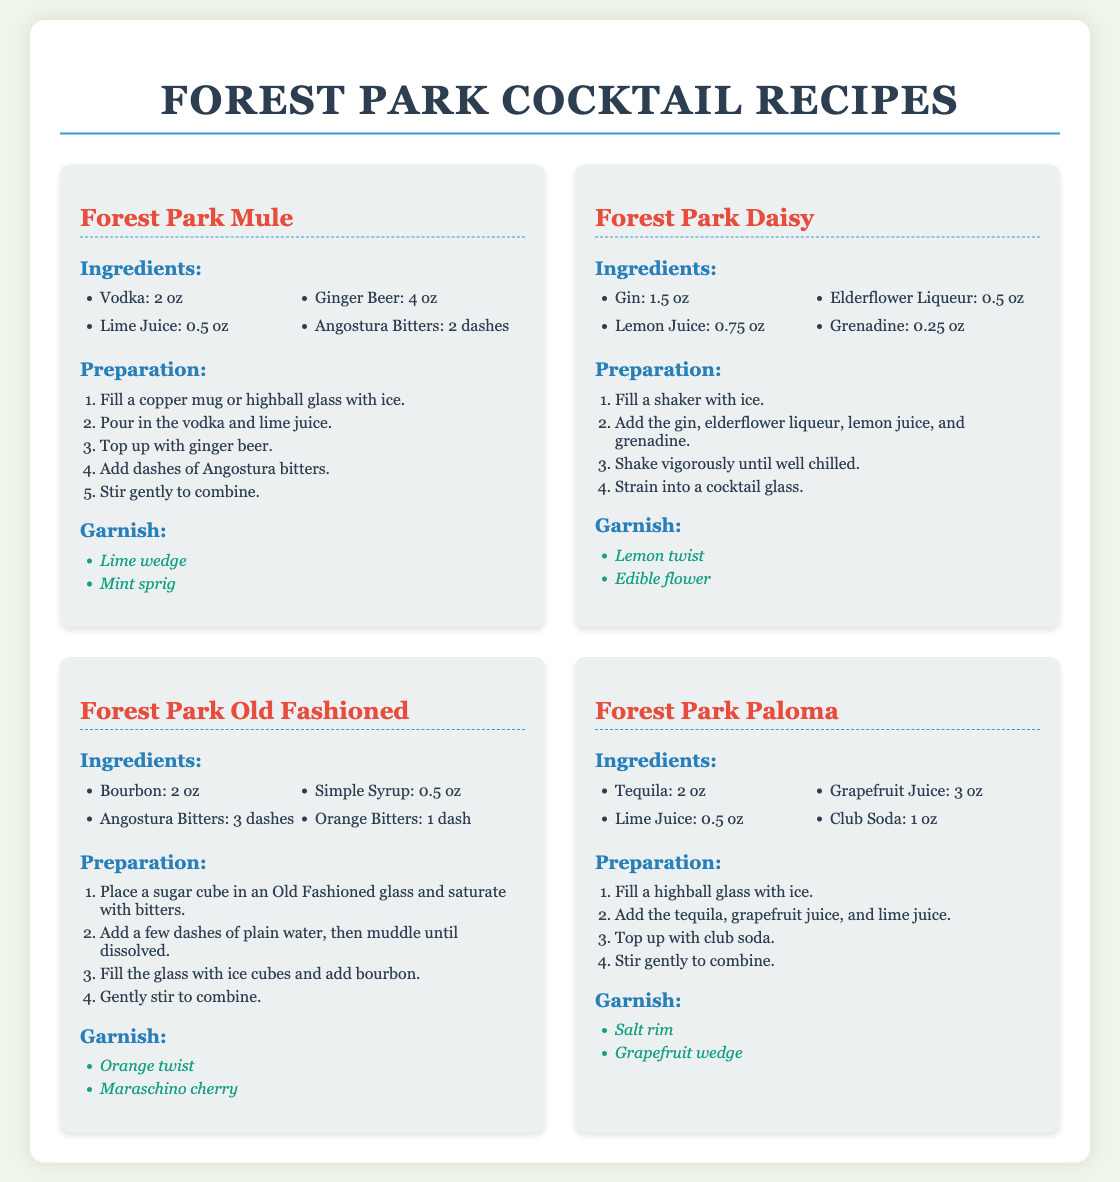What is the first cocktail listed? The first cocktail shown in the recipe card is "Forest Park Mule."
Answer: Forest Park Mule How many ounces of vodka are needed for the Forest Park Mule? The Forest Park Mule recipe specifies 2 ounces of vodka.
Answer: 2 oz What is the garnish for the Forest Park Daisy? The recipe indicates that the garnishes for the Forest Park Daisy include a lemon twist and an edible flower.
Answer: Lemon twist, Edible flower How many ingredients are used in the Forest Park Old Fashioned? The Forest Park Old Fashioned recipe lists a total of four ingredients.
Answer: 4 What type of glass is recommended for the Forest Park Mule? The recipe suggests using a copper mug or a highball glass for serving the Forest Park Mule.
Answer: Copper mug or highball glass What is the primary spirit used in the Forest Park Paloma? The main spirit in the Forest Park Paloma recipe is tequila.
Answer: Tequila How is the Forest Park Daisy prepared? The preparation of the Forest Park Daisy involves filling a shaker with ice, adding ingredients, shaking, and then straining into a cocktail glass.
Answer: Shake and strain What dashes are added to the Forest Park Mule? The recipe specifies adding 2 dashes of Angostura bitters to the Forest Park Mule.
Answer: 2 dashes What is the total volume of liquid in ounces in the Forest Park Paloma before garnishing? The total volume for liquid ingredients before garnishing in the Forest Park Paloma is 5.5 ounces (2 oz tequila, 3 oz grapefruit juice, 0.5 oz lime juice, and 1 oz club soda).
Answer: 5.5 oz 